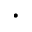<formula> <loc_0><loc_0><loc_500><loc_500>\cdot</formula> 